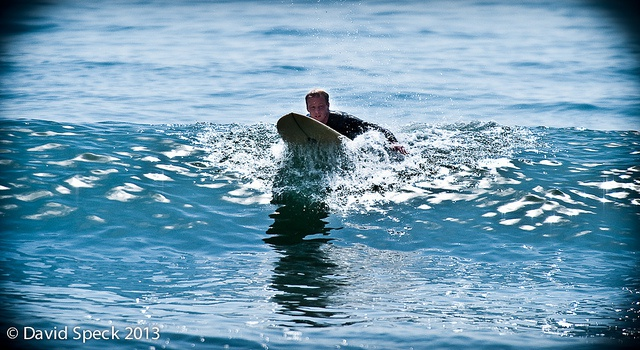Describe the objects in this image and their specific colors. I can see people in black, lightgray, and gray tones and surfboard in black, purple, gray, and lightgray tones in this image. 